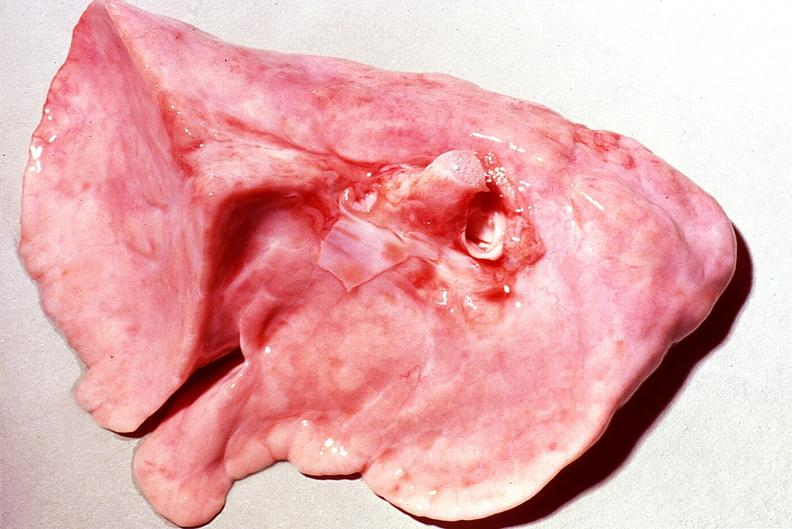does this image show normal lung?
Answer the question using a single word or phrase. Yes 